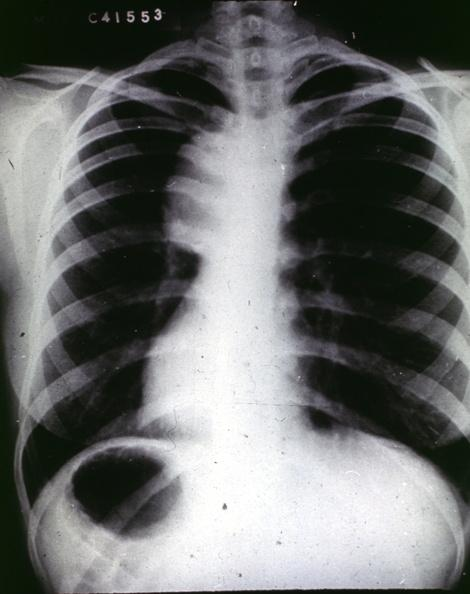does this image show traumatic aneurysm aortogram?
Answer the question using a single word or phrase. Yes 